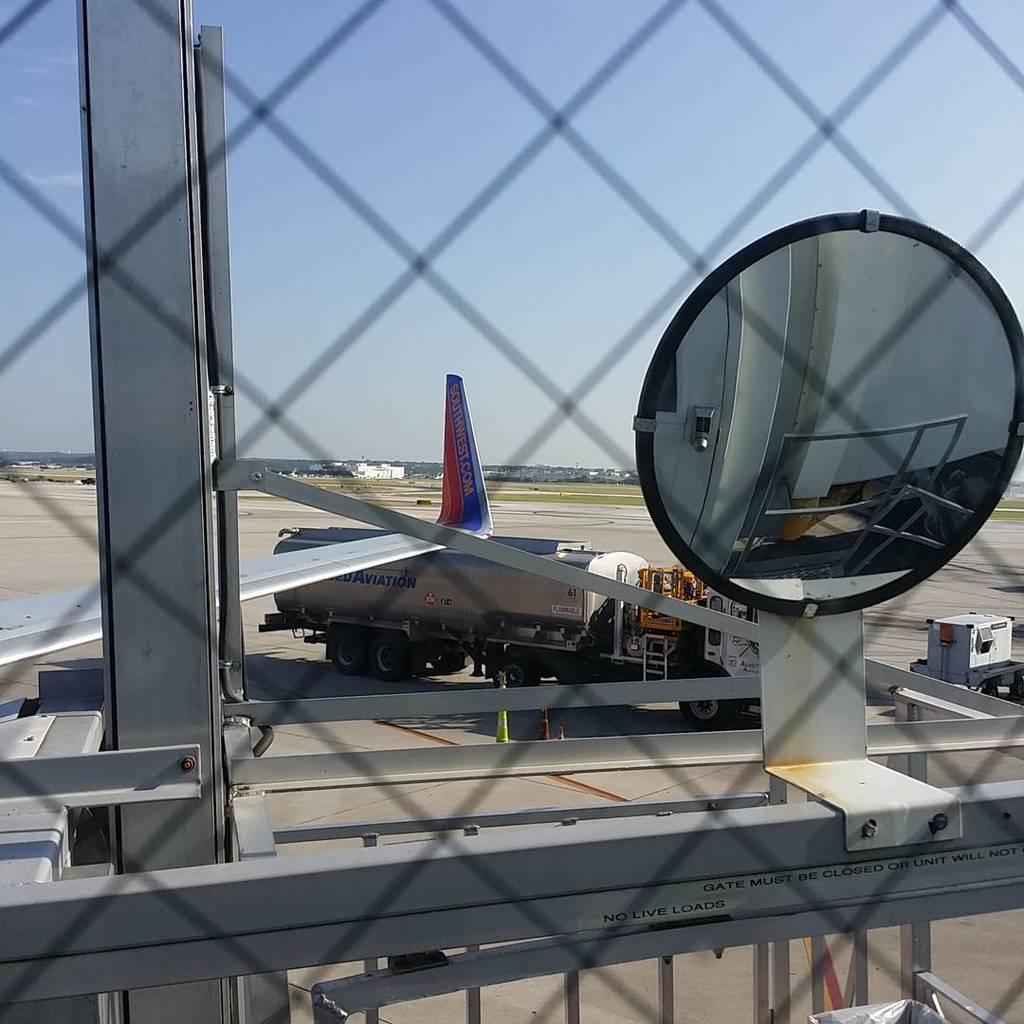What king of loads are not allowed?
Your answer should be very brief. Live. What airline is this plane?
Your answer should be very brief. Southwest. 